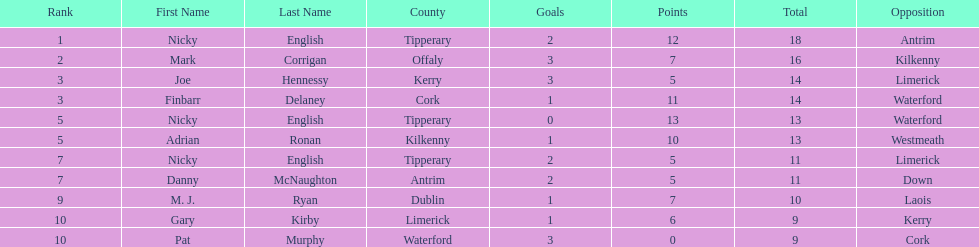How many people are on the list? 9. 